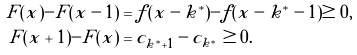<formula> <loc_0><loc_0><loc_500><loc_500>F ( x ) - F ( x - 1 ) & = f ( x - k ^ { * } ) - f ( x - k ^ { * } - 1 ) \geq 0 , \\ F ( x + 1 ) - F ( x ) & = c _ { k ^ { * } + 1 } - c _ { k ^ { * } } \geq 0 .</formula> 